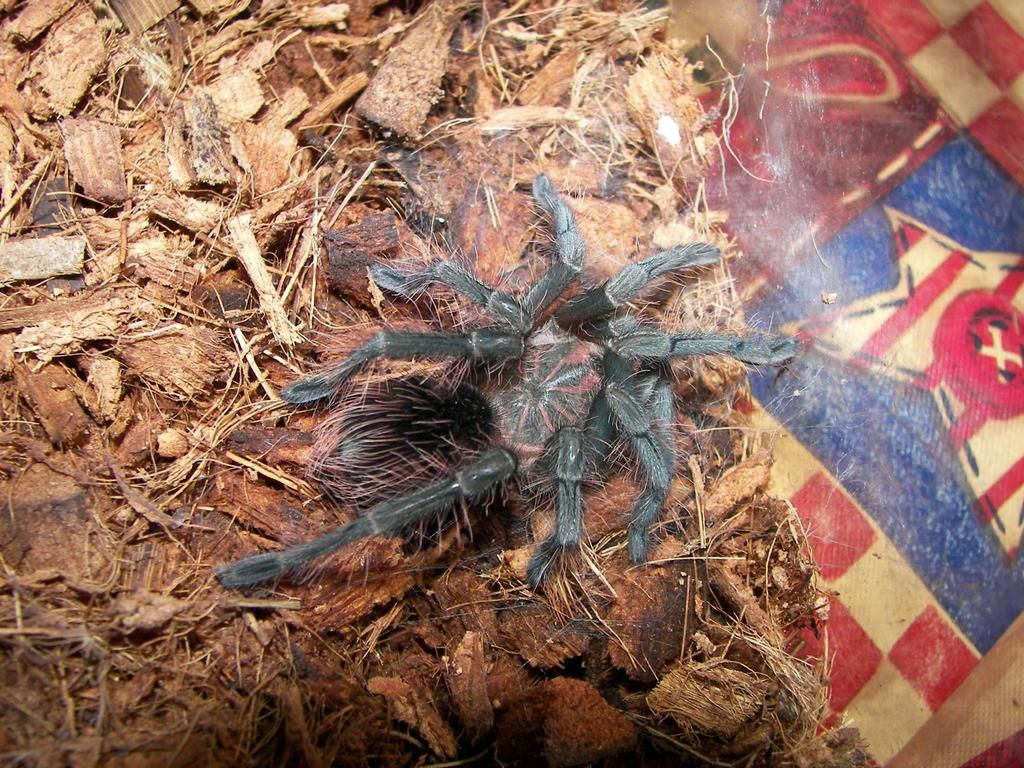What type of creature can be seen in the image? There is an insect in the image. What is the insect sitting on? The insect is on wood waste. Can you describe the design on the right side of the image? Unfortunately, there is no information about a design on the right side of the image. What type of sleet can be seen falling in the image? There is no sleet present in the image. How does the insect provide a thrill in the image? The insect does not provide a thrill in the image; it is simply sitting on wood waste. 